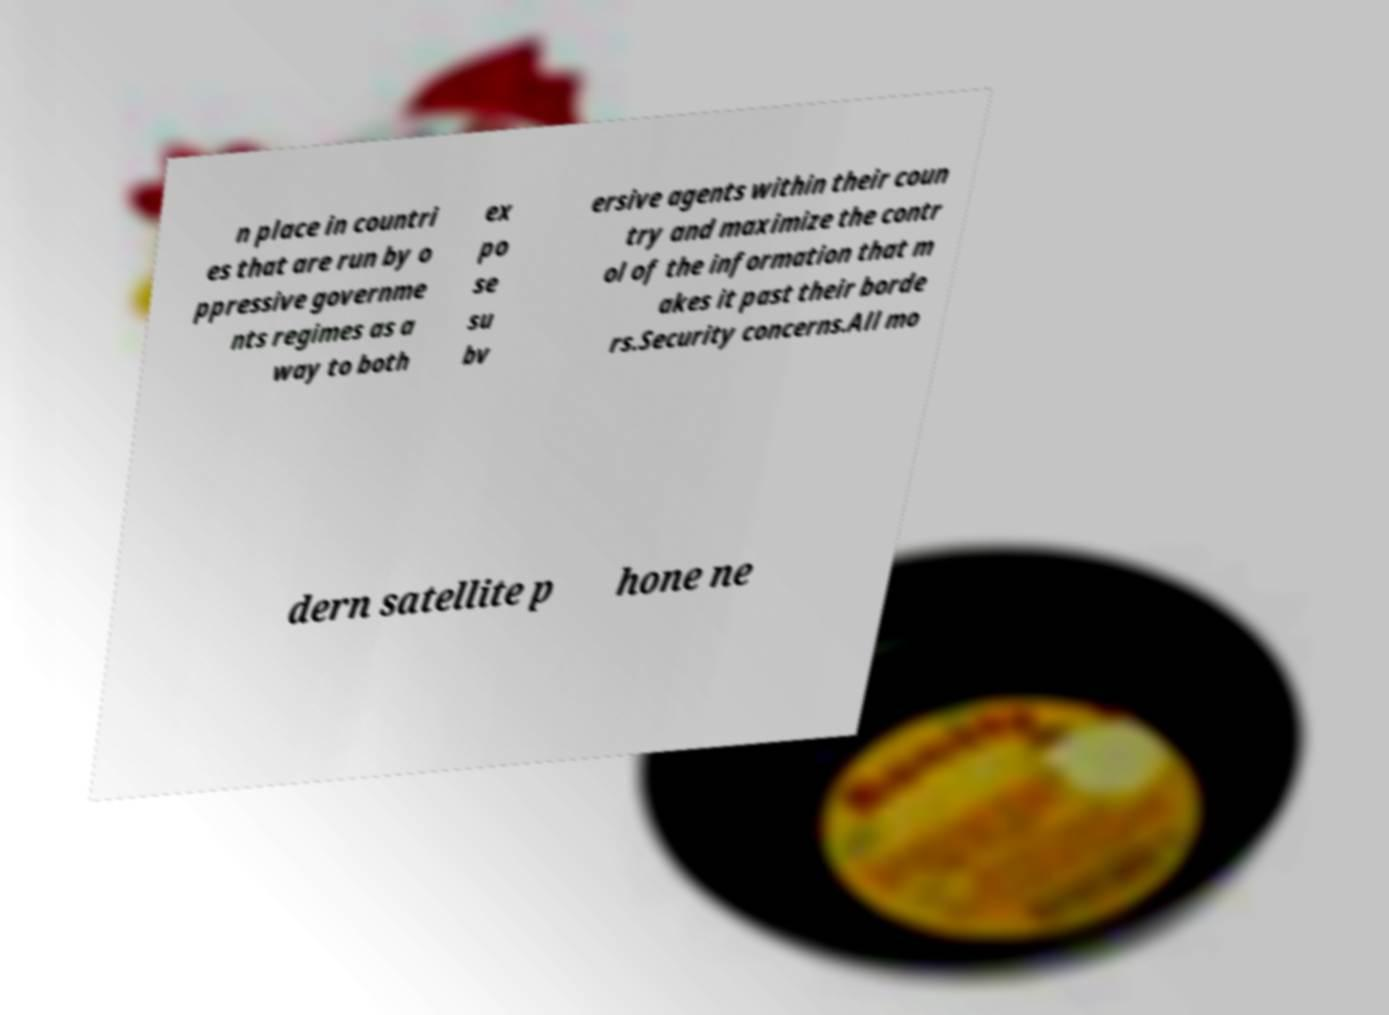Could you extract and type out the text from this image? n place in countri es that are run by o ppressive governme nts regimes as a way to both ex po se su bv ersive agents within their coun try and maximize the contr ol of the information that m akes it past their borde rs.Security concerns.All mo dern satellite p hone ne 